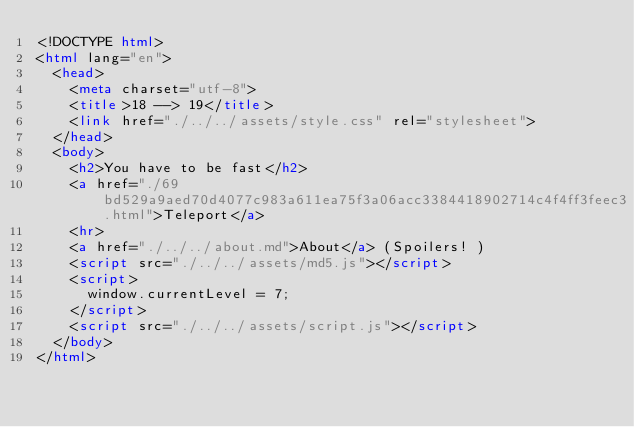Convert code to text. <code><loc_0><loc_0><loc_500><loc_500><_HTML_><!DOCTYPE html>
<html lang="en">
  <head>
    <meta charset="utf-8">
    <title>18 --> 19</title>
    <link href="./../../assets/style.css" rel="stylesheet">
  </head>
  <body>
    <h2>You have to be fast</h2>
    <a href="./69bd529a9aed70d4077c983a611ea75f3a06acc3384418902714c4f4ff3feec3.html">Teleport</a>
    <hr>
    <a href="./../../about.md">About</a> (Spoilers! )
    <script src="./../../assets/md5.js"></script>
    <script>
      window.currentLevel = 7;
    </script>
    <script src="./../../assets/script.js"></script>
  </body>
</html></code> 